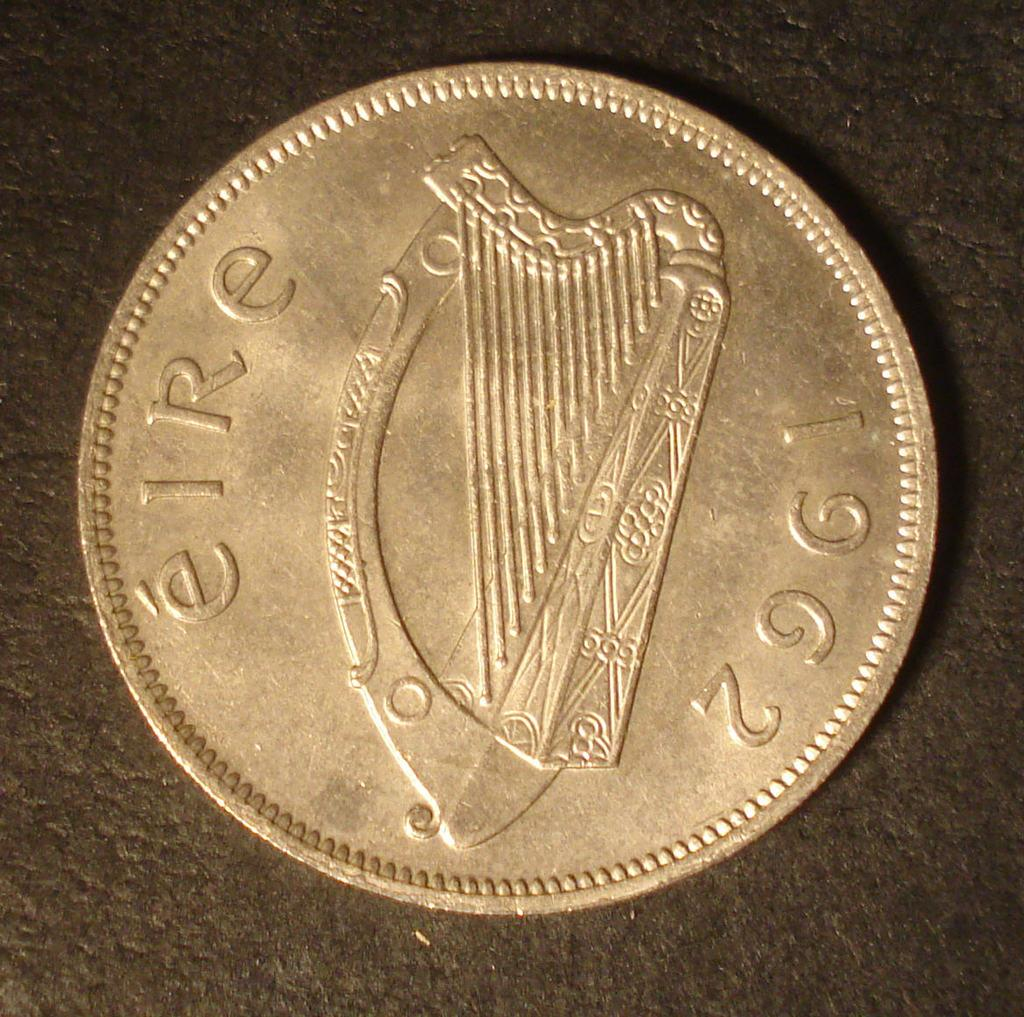<image>
Describe the image concisely. A coin has the year of 1962 inscribed near the edge of it. 